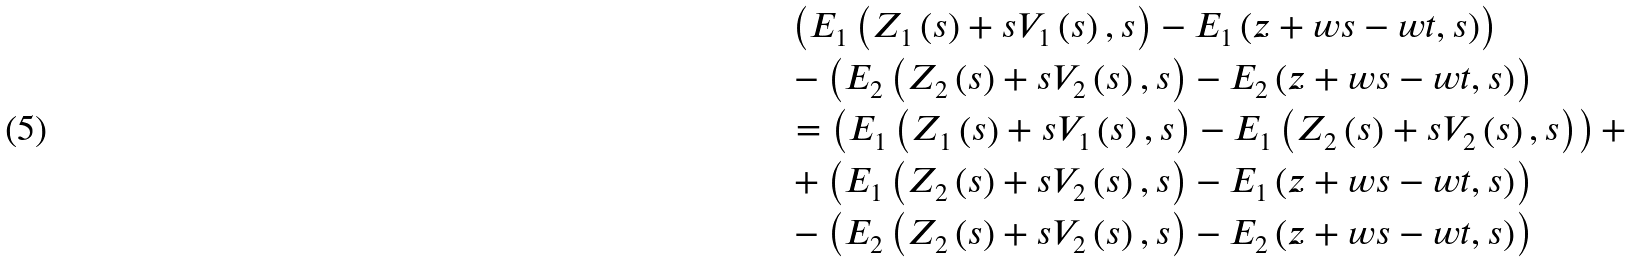<formula> <loc_0><loc_0><loc_500><loc_500>& \left ( E _ { 1 } \left ( Z _ { 1 } \left ( s \right ) + s V _ { 1 } \left ( s \right ) , s \right ) - E _ { 1 } \left ( z + w s - w t , s \right ) \right ) \\ & - \left ( E _ { 2 } \left ( Z _ { 2 } \left ( s \right ) + s V _ { 2 } \left ( s \right ) , s \right ) - E _ { 2 } \left ( z + w s - w t , s \right ) \right ) \\ & = \left ( E _ { 1 } \left ( Z _ { 1 } \left ( s \right ) + s V _ { 1 } \left ( s \right ) , s \right ) - E _ { 1 } \left ( Z _ { 2 } \left ( s \right ) + s V _ { 2 } \left ( s \right ) , s \right ) \right ) + \\ & + \left ( E _ { 1 } \left ( Z _ { 2 } \left ( s \right ) + s V _ { 2 } \left ( s \right ) , s \right ) - E _ { 1 } \left ( z + w s - w t , s \right ) \right ) \\ & - \left ( E _ { 2 } \left ( Z _ { 2 } \left ( s \right ) + s V _ { 2 } \left ( s \right ) , s \right ) - E _ { 2 } \left ( z + w s - w t , s \right ) \right )</formula> 